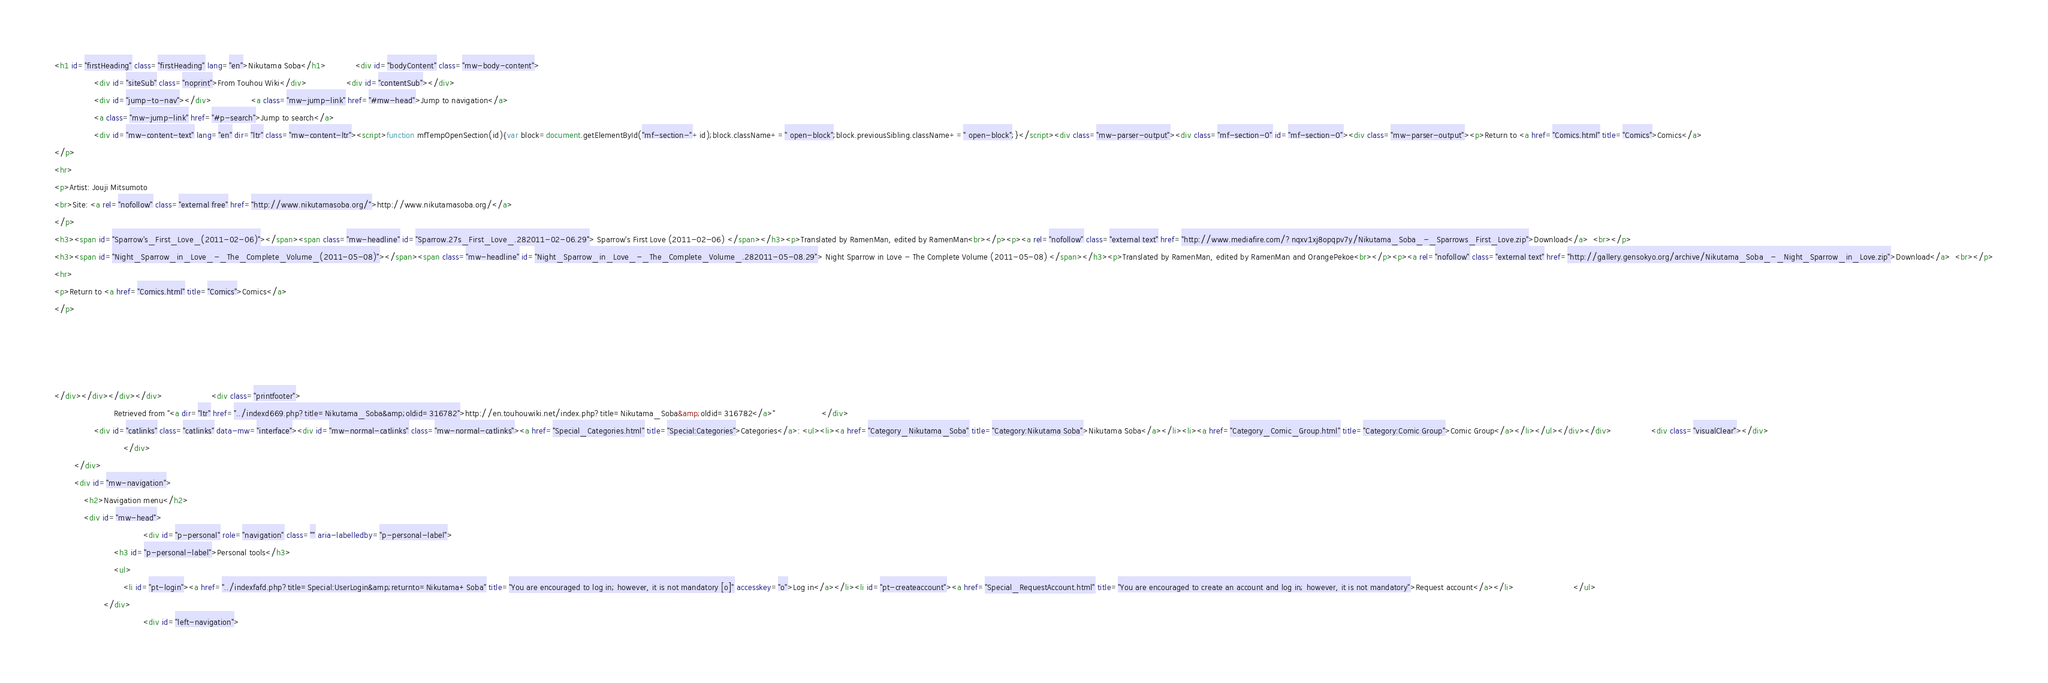<code> <loc_0><loc_0><loc_500><loc_500><_HTML_><h1 id="firstHeading" class="firstHeading" lang="en">Nikutama Soba</h1>			<div id="bodyContent" class="mw-body-content">
				<div id="siteSub" class="noprint">From Touhou Wiki</div>				<div id="contentSub"></div>
				<div id="jump-to-nav"></div>				<a class="mw-jump-link" href="#mw-head">Jump to navigation</a>
				<a class="mw-jump-link" href="#p-search">Jump to search</a>
				<div id="mw-content-text" lang="en" dir="ltr" class="mw-content-ltr"><script>function mfTempOpenSection(id){var block=document.getElementById("mf-section-"+id);block.className+=" open-block";block.previousSibling.className+=" open-block";}</script><div class="mw-parser-output"><div class="mf-section-0" id="mf-section-0"><div class="mw-parser-output"><p>Return to <a href="Comics.html" title="Comics">Comics</a>
</p>
<hr>
<p>Artist: Jouji Mitsumoto
<br>Site: <a rel="nofollow" class="external free" href="http://www.nikutamasoba.org/">http://www.nikutamasoba.org/</a>
</p>
<h3><span id="Sparrow's_First_Love_(2011-02-06)"></span><span class="mw-headline" id="Sparrow.27s_First_Love_.282011-02-06.29"> Sparrow's First Love (2011-02-06) </span></h3><p>Translated by RamenMan, edited by RamenMan<br></p><p><a rel="nofollow" class="external text" href="http://www.mediafire.com/?nqxv1xj8opqpv7y/Nikutama_Soba_-_Sparrows_First_Love.zip">Download</a>  <br></p>
<h3><span id="Night_Sparrow_in_Love_-_The_Complete_Volume_(2011-05-08)"></span><span class="mw-headline" id="Night_Sparrow_in_Love_-_The_Complete_Volume_.282011-05-08.29"> Night Sparrow in Love - The Complete Volume (2011-05-08) </span></h3><p>Translated by RamenMan, edited by RamenMan and OrangePekoe<br></p><p><a rel="nofollow" class="external text" href="http://gallery.gensokyo.org/archive/Nikutama_Soba_-_Night_Sparrow_in_Love.zip">Download</a>  <br></p>
<hr>
<p>Return to <a href="Comics.html" title="Comics">Comics</a>
</p>




</div></div></div></div>					<div class="printfooter">
						Retrieved from "<a dir="ltr" href="../indexd669.php?title=Nikutama_Soba&amp;oldid=316782">http://en.touhouwiki.net/index.php?title=Nikutama_Soba&amp;oldid=316782</a>"					</div>
				<div id="catlinks" class="catlinks" data-mw="interface"><div id="mw-normal-catlinks" class="mw-normal-catlinks"><a href="Special_Categories.html" title="Special:Categories">Categories</a>: <ul><li><a href="Category_Nikutama_Soba" title="Category:Nikutama Soba">Nikutama Soba</a></li><li><a href="Category_Comic_Group.html" title="Category:Comic Group">Comic Group</a></li></ul></div></div>				<div class="visualClear"></div>
							</div>
		</div>
		<div id="mw-navigation">
			<h2>Navigation menu</h2>
			<div id="mw-head">
									<div id="p-personal" role="navigation" class="" aria-labelledby="p-personal-label">
						<h3 id="p-personal-label">Personal tools</h3>
						<ul>
							<li id="pt-login"><a href="../indexfafd.php?title=Special:UserLogin&amp;returnto=Nikutama+Soba" title="You are encouraged to log in; however, it is not mandatory [o]" accesskey="o">Log in</a></li><li id="pt-createaccount"><a href="Special_RequestAccount.html" title="You are encouraged to create an account and log in; however, it is not mandatory">Request account</a></li>						</ul>
					</div>
									<div id="left-navigation"></code> 